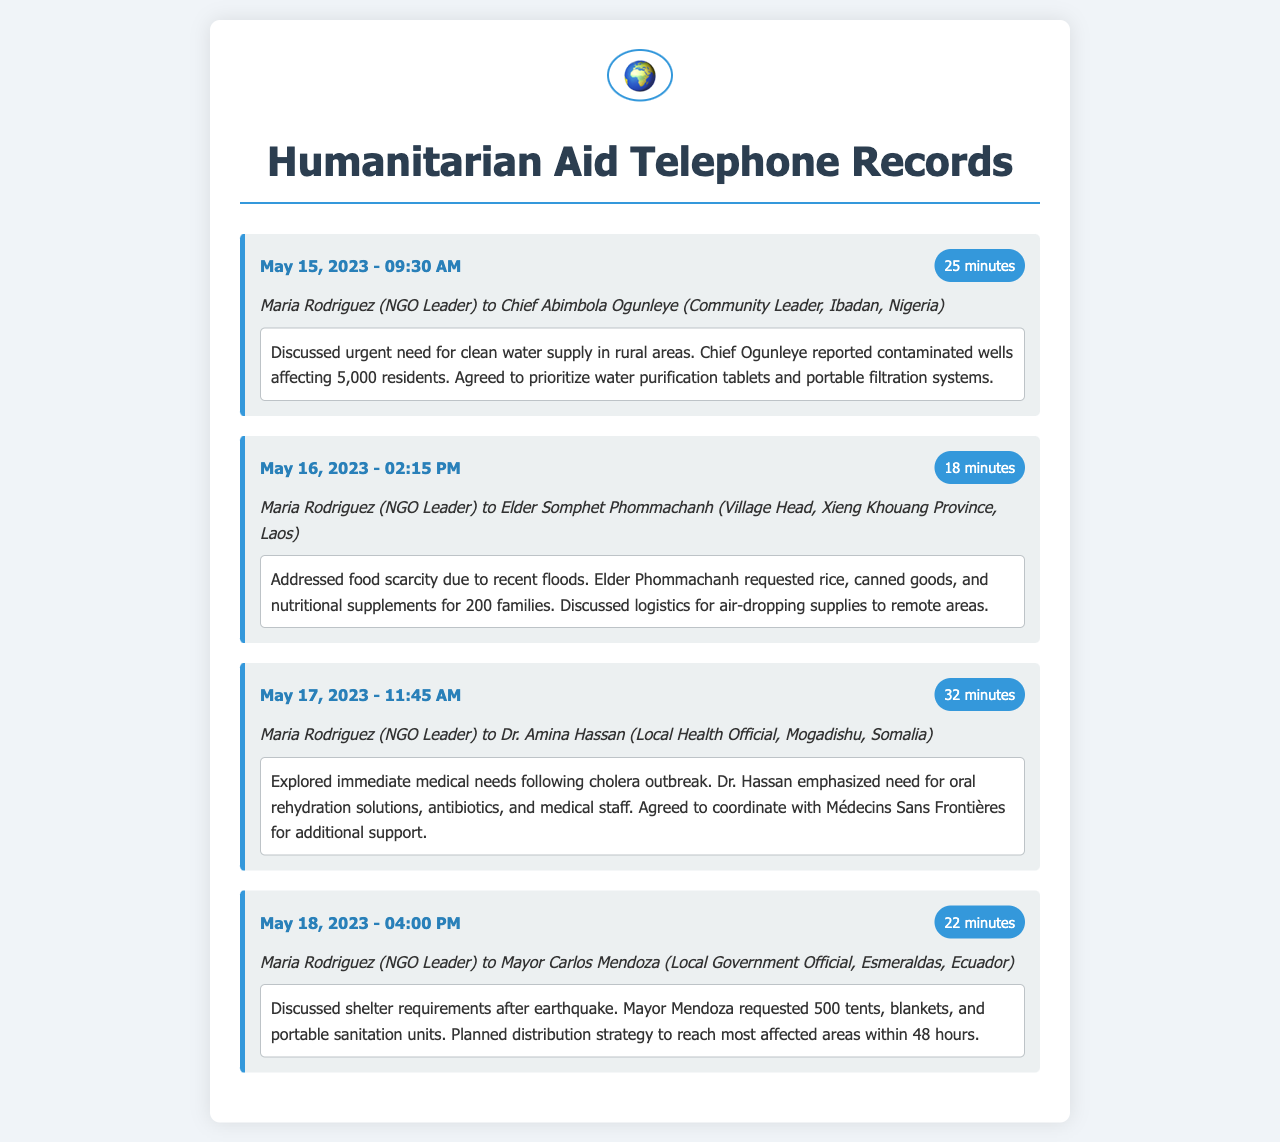What was discussed on May 15, 2023? The conversation on May 15, 2023, focused on the urgent need for clean water supply in rural areas.
Answer: Clean water supply How many residents were affected by contaminated wells in Ibadan? Chief Ogunleye reported that contaminated wells were affecting 5,000 residents.
Answer: 5,000 What supplies did Elder Phommachanh request for 200 families? Elder Phommachanh requested rice, canned goods, and nutritional supplements.
Answer: Rice, canned goods, nutritional supplements Which organization's support was mentioned for coordinating additional medical assistance? The conversation included coordinating with Médecins Sans Frontières for additional support.
Answer: Médecins Sans Frontières How many tents did Mayor Mendoza request after the earthquake? Mayor Mendoza requested 500 tents for shelter following the earthquake.
Answer: 500 tents What was the duration of the call with Chief Abimbola Ogunleye? The call with Chief Abimbola Ogunleye lasted for 25 minutes.
Answer: 25 minutes Which city was associated with Dr. Amina Hassan in the telephone record? Dr. Amina Hassan was associated with Mogadishu in the record.
Answer: Mogadishu What type of emergency was addressed in the call on May 17, 2023? The emergency addressed was a cholera outbreak.
Answer: Cholera outbreak 